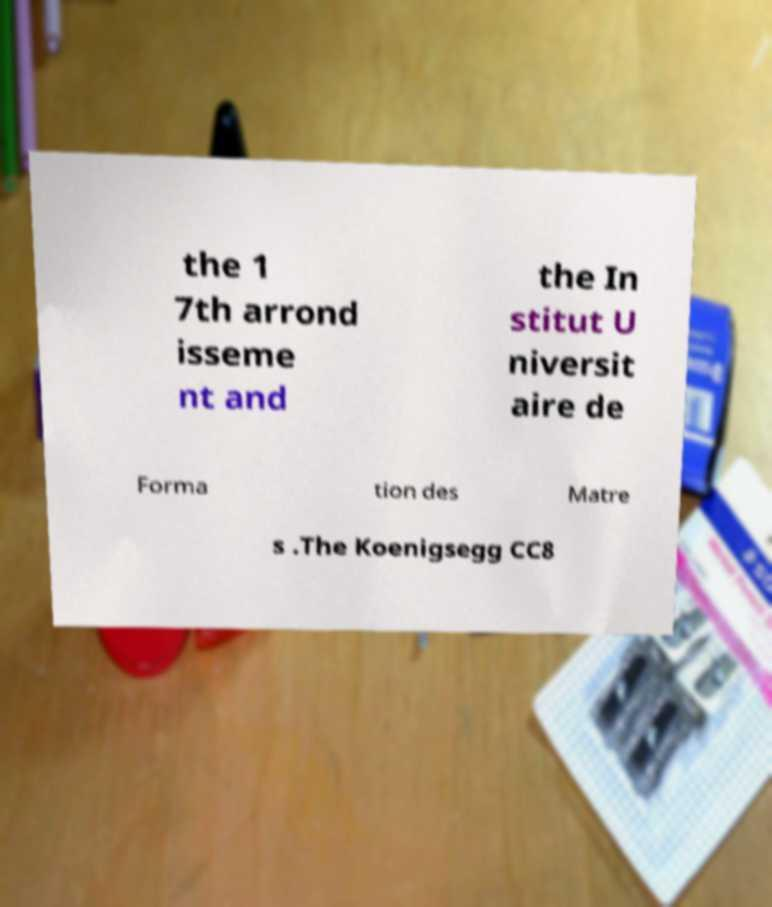I need the written content from this picture converted into text. Can you do that? the 1 7th arrond isseme nt and the In stitut U niversit aire de Forma tion des Matre s .The Koenigsegg CC8 